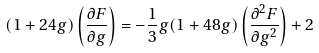<formula> <loc_0><loc_0><loc_500><loc_500>( 1 + 2 4 g ) \left ( \frac { \partial F } { \partial g } \right ) = - \frac { 1 } { 3 } g ( 1 + 4 8 g ) \left ( \frac { \partial ^ { 2 } F } { \partial g ^ { 2 } } \right ) + 2</formula> 